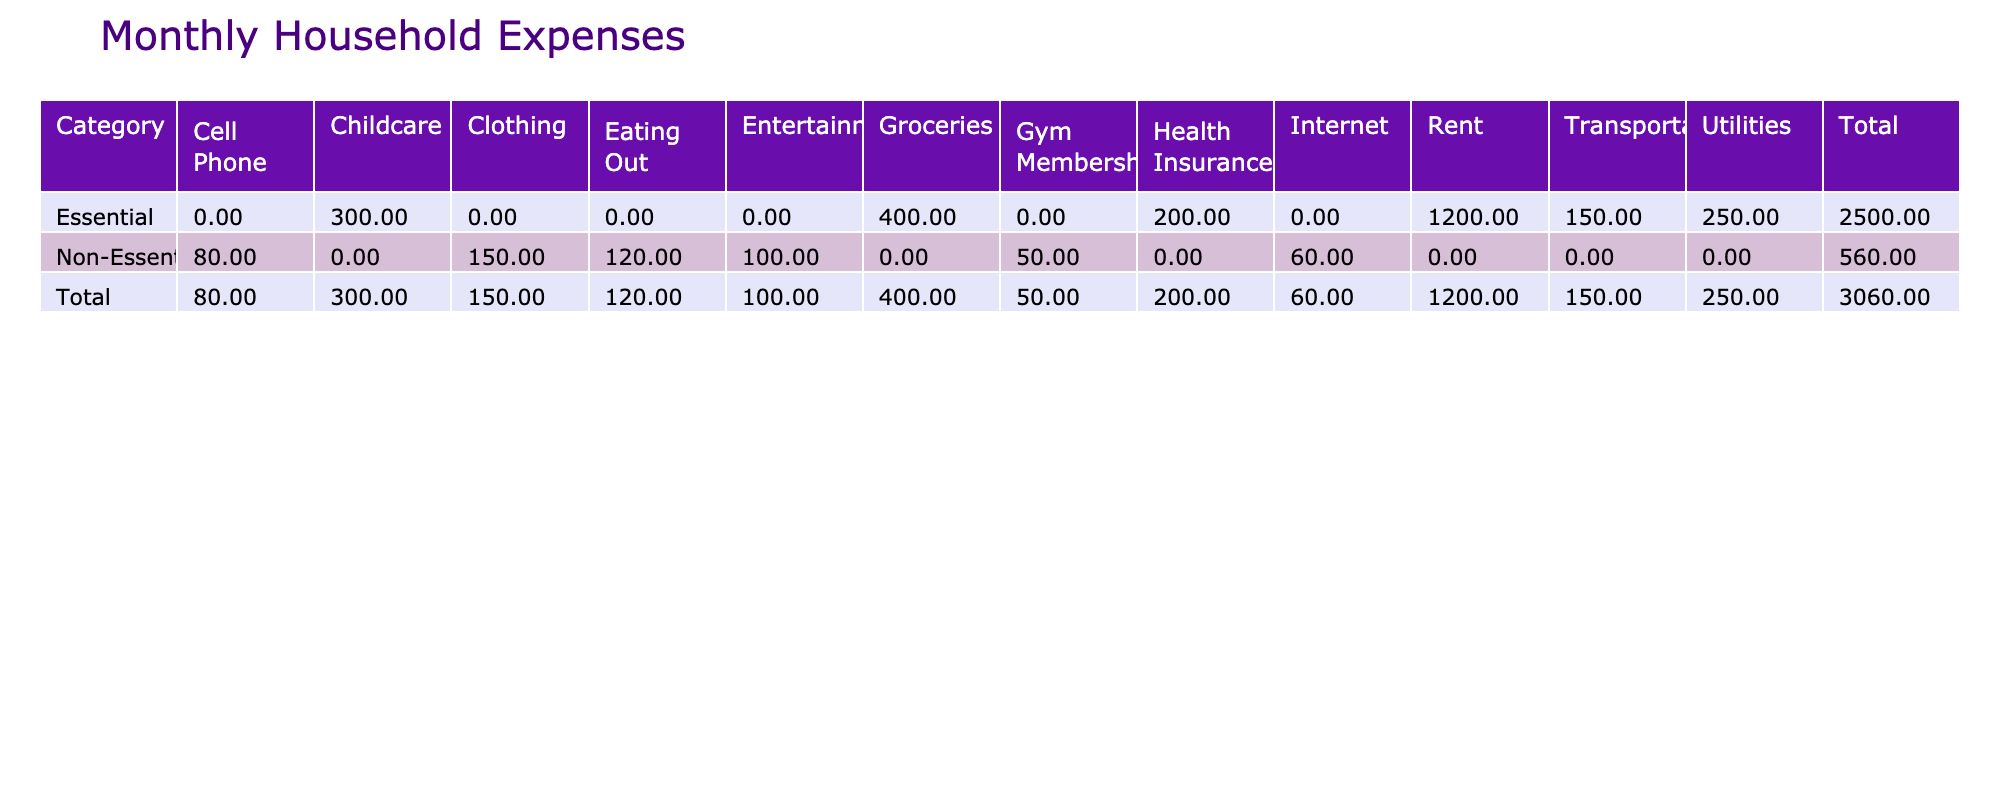What is the total amount spent on essential items? To find the total amount for essential items, I will sum the values in the 'Amount' column under the 'Essential' category. The values are 1200 for Rent, 400 for Groceries, 250 for Utilities, 150 for Transportation, 300 for Childcare, and 200 for Health Insurance. Adding these gives 1200 + 400 + 250 + 150 + 300 + 200 = 2550.
Answer: 2550 How much do the non-essential items total? I need to sum the values for the 'Non-Essential' items. The relevant amounts are 60 for Internet, 80 for Cell Phone, 150 for Clothing, 100 for Entertainment, 120 for Eating Out, and 50 for Gym Membership. Adding these amounts results in 60 + 80 + 150 + 100 + 120 + 50 = 560.
Answer: 560 Is the amount spent on Transportation greater than the amount spent on Gym Membership? I will compare the amounts: Transportation is 150 and Gym Membership is 50. Since 150 is greater than 50, the statement is true.
Answer: Yes What is the average spending on essential household items? First, I need to add up the total amount spent on essential items, which is 2550. There are 6 different essential items. To find the average, I will divide the total by the number of items: 2550 / 6 = 425.
Answer: 425 Which non-essential item has the highest spending? I will look at the 'Amount' values of the non-essential items: Internet (60), Cell Phone (80), Clothing (150), Entertainment (100), Eating Out (120), and Gym Membership (50). Clothing has the highest amount of 150.
Answer: Clothing What is the total of all monthly household expenses? To calculate the total expenses, I will add the total for essential items (2550) and the total for non-essential items (560). Therefore, 2550 + 560 = 3110.
Answer: 3110 Is the total amount spent on Childcare more than that on Eating Out? I will check the amounts: Childcare is 300 and Eating Out is 120. Since 300 is greater than 120, the statement is true.
Answer: Yes What is the difference in spending between Rent and Entertainment? I will find the amounts: Rent is 1200, and Entertainment is 100. The difference is calculated as 1200 - 100 = 1100.
Answer: 1100 